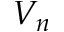<formula> <loc_0><loc_0><loc_500><loc_500>V _ { n }</formula> 